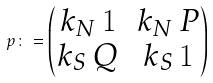<formula> <loc_0><loc_0><loc_500><loc_500>p \colon = \begin{pmatrix} k _ { N } \, \mathbf 1 & k _ { N } \, P \\ k _ { S } \, Q & k _ { S } \, \mathbf 1 \end{pmatrix}</formula> 